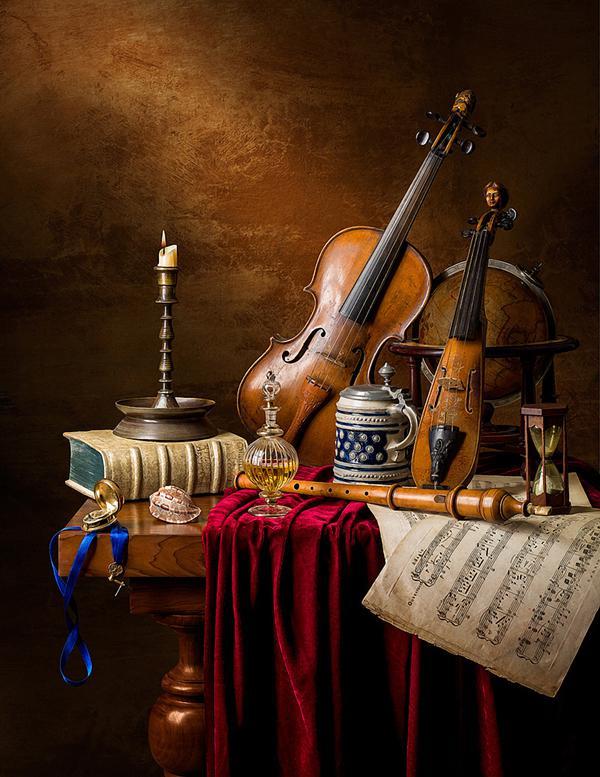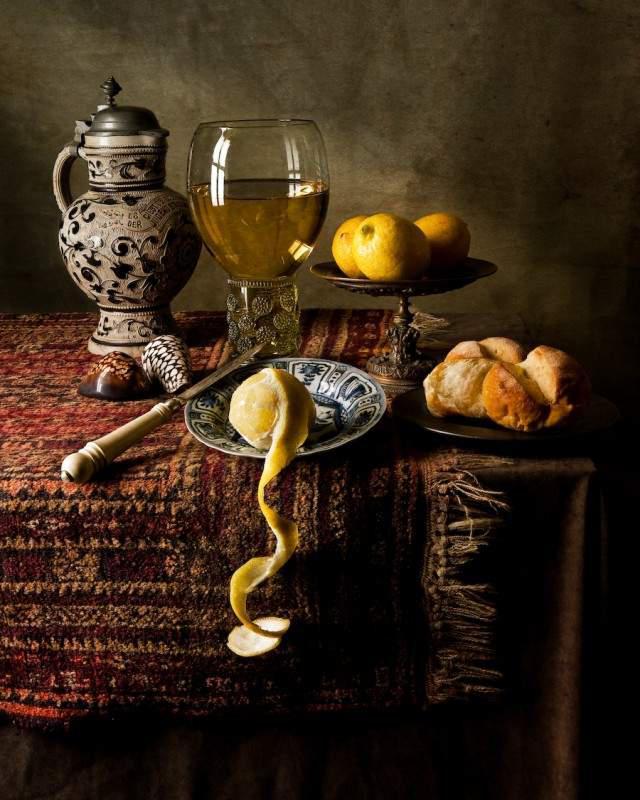The first image is the image on the left, the second image is the image on the right. Considering the images on both sides, is "The image on the left shows an instrumental group with at least four members, and all members sitting on chairs." valid? Answer yes or no. No. The first image is the image on the left, the second image is the image on the right. Considering the images on both sides, is "The image on the left shows a violin player and a flute player sitting side by side." valid? Answer yes or no. No. 